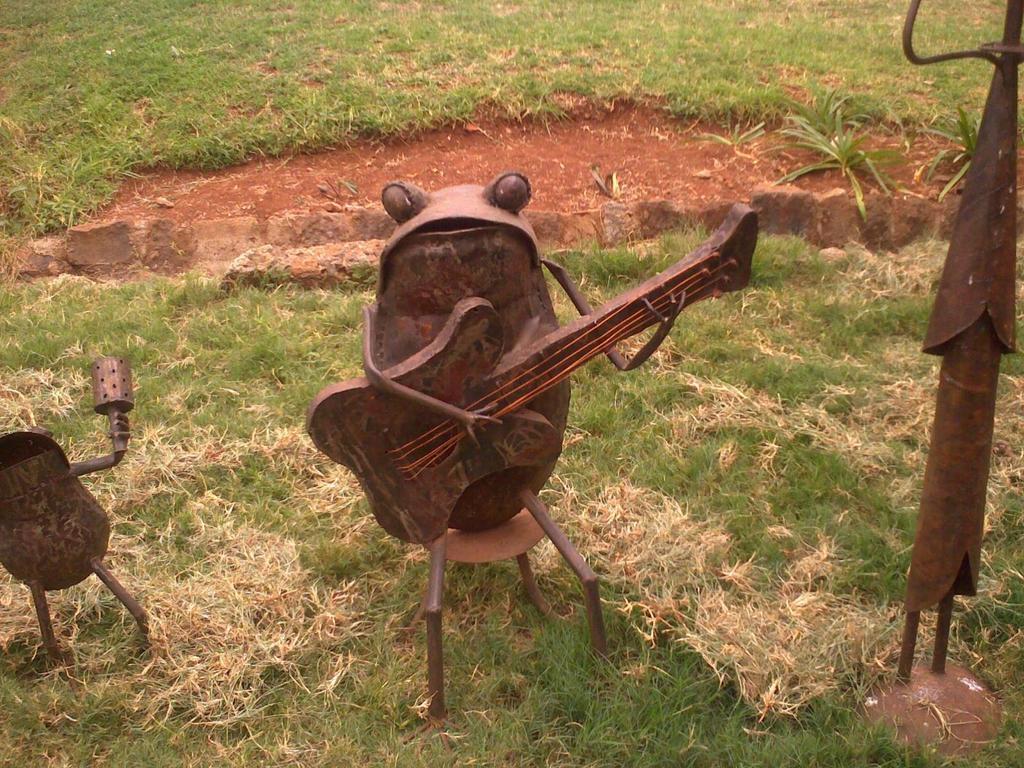Can you describe this image briefly? In this image we can see a grassy land. There are few metallic crafts in the image. 